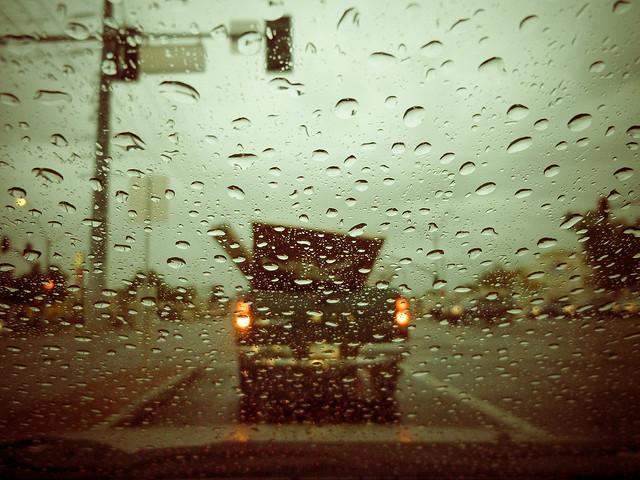Is it raining?
Concise answer only. Yes. What are on the screen?
Be succinct. Raindrops. What vehicle is parked in front?
Keep it brief. Truck. 